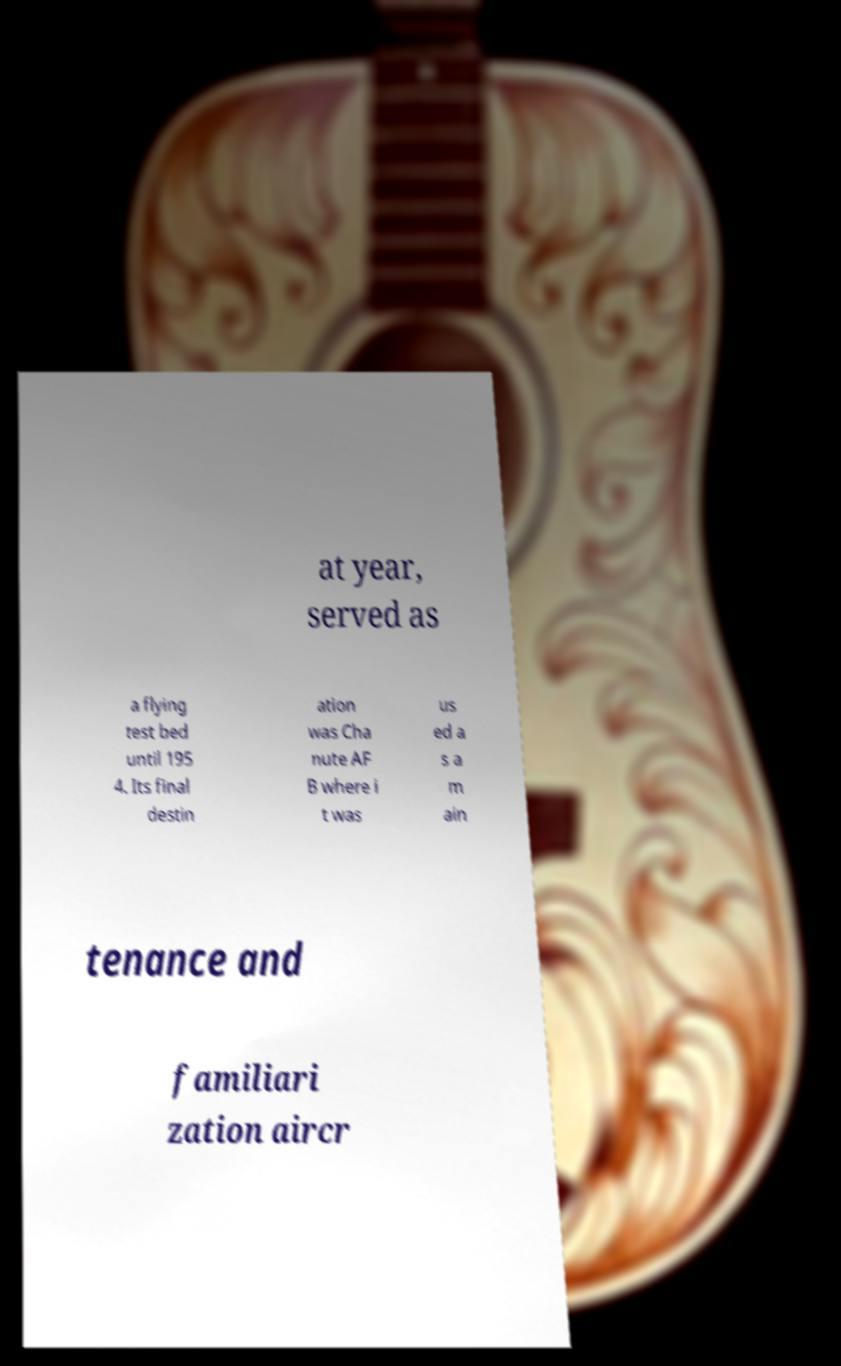There's text embedded in this image that I need extracted. Can you transcribe it verbatim? at year, served as a flying test bed until 195 4. Its final destin ation was Cha nute AF B where i t was us ed a s a m ain tenance and familiari zation aircr 